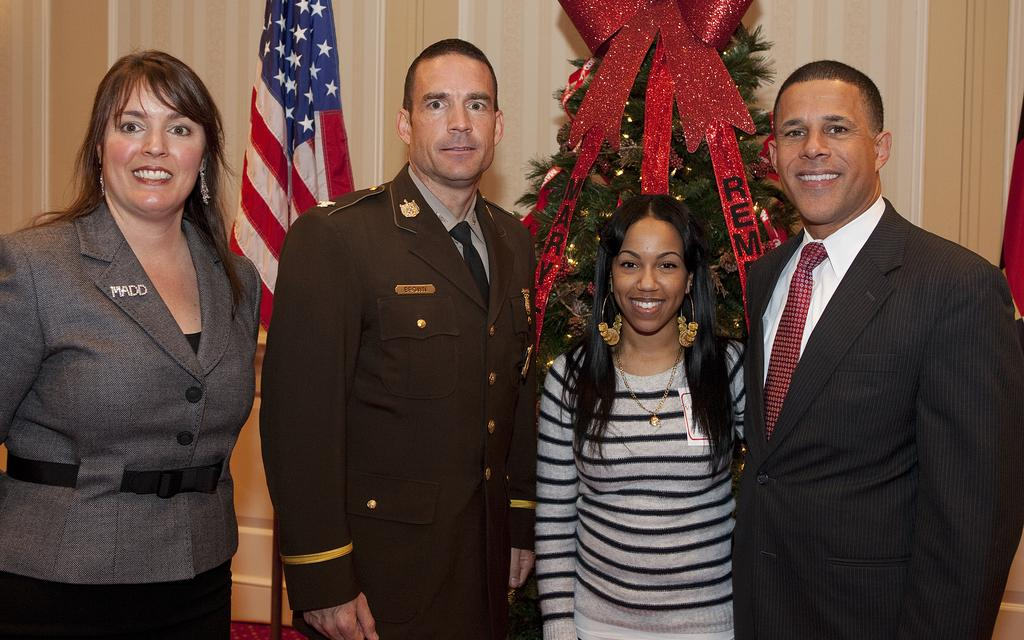How many people are present in the image? There are four people in the image. What is the facial expression of the people in the image? The people are standing with smiles on their faces. What is a prominent feature in the image related to a holiday? There is a Christmas tree in the image. What is another object present in the image? There is a flag in the image. What can be seen in the background of the image? There is a wall visible in the background of the image. How many jellyfish are swimming near the people in the image? There are no jellyfish present in the image. What type of behavior is the pail exhibiting in the image? There is no pail present in the image. 